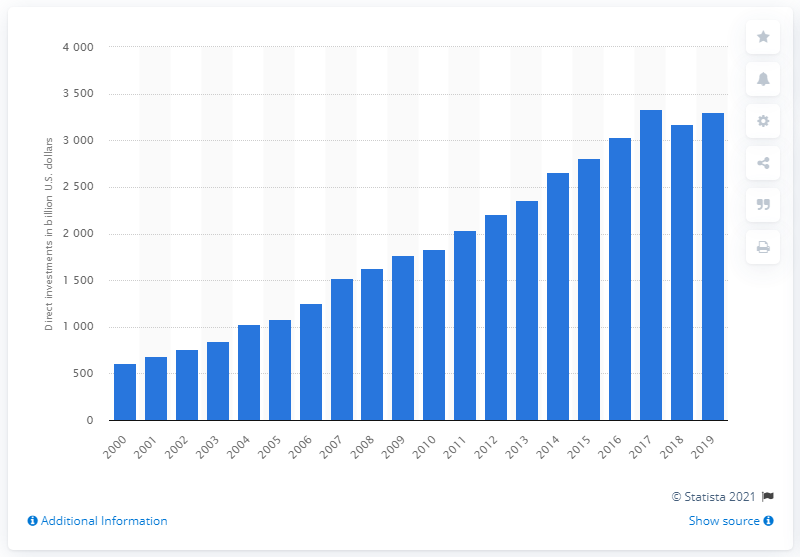List a handful of essential elements in this visual. In 2019, the direct investments by the United States in the European Union totaled approximately 33,312.80 dollars. 